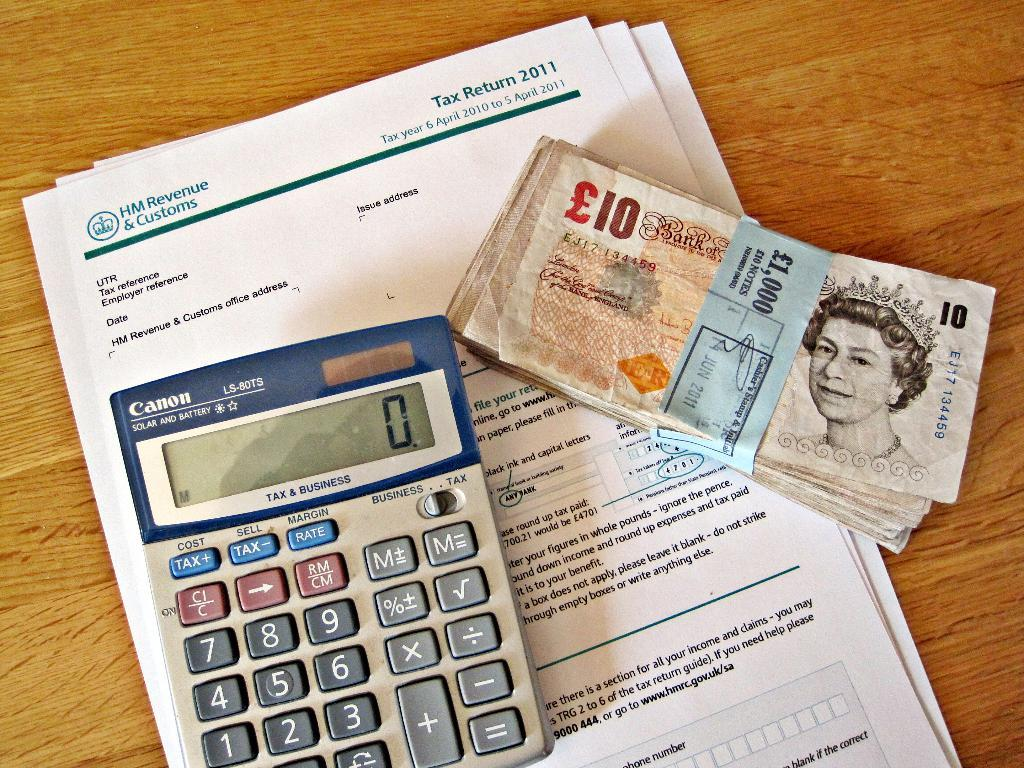Provide a one-sentence caption for the provided image. A cannon calculator sitting on top of tax return 2011 papers and some british money on the side. 